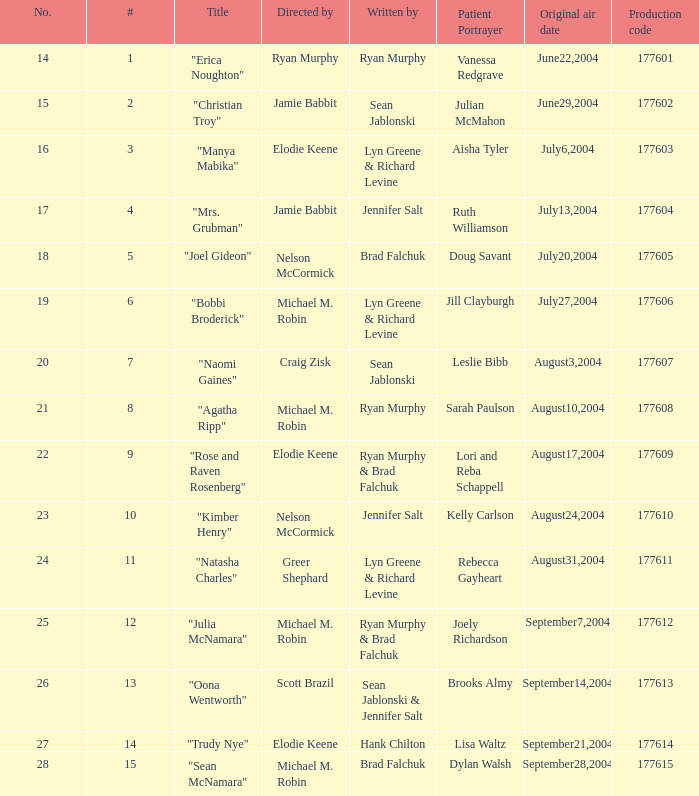Who wrote episode number 28? Brad Falchuk. 